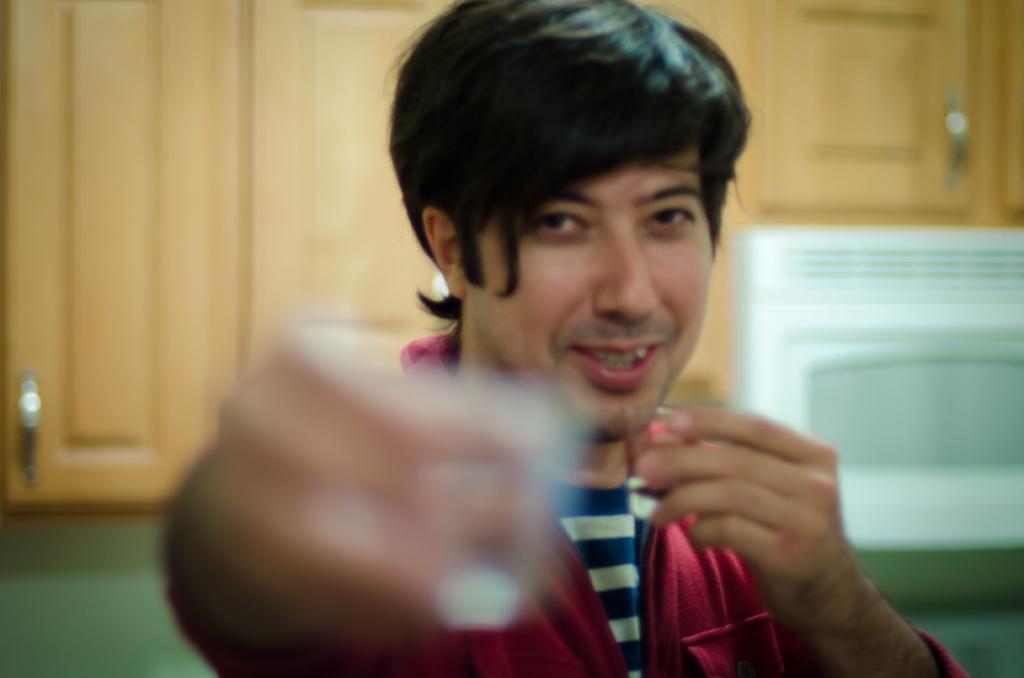Could you give a brief overview of what you see in this image? In this picture I can see there is a man standing here and smiling, he is holding a object here in the left hand. In the backdrop I can see there are some shelves and there is a wall. 